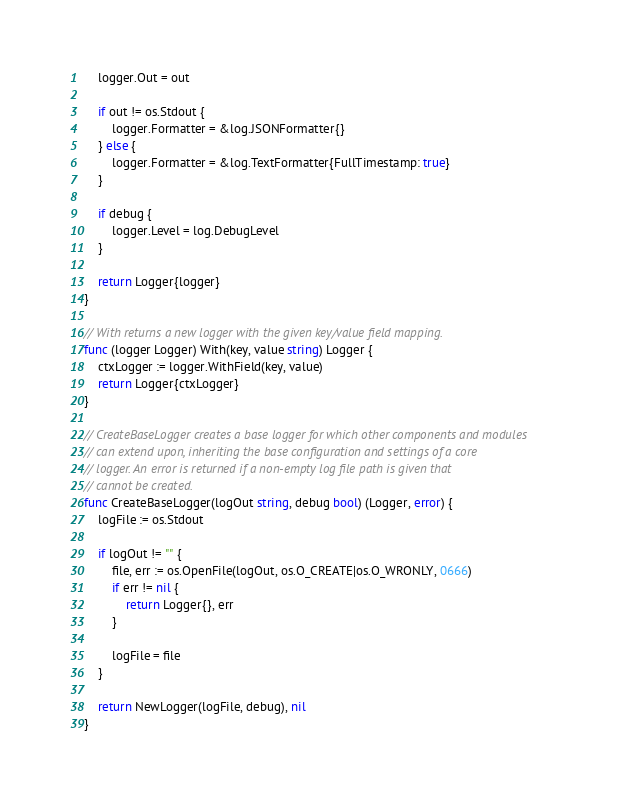<code> <loc_0><loc_0><loc_500><loc_500><_Go_>	logger.Out = out

	if out != os.Stdout {
		logger.Formatter = &log.JSONFormatter{}
	} else {
		logger.Formatter = &log.TextFormatter{FullTimestamp: true}
	}

	if debug {
		logger.Level = log.DebugLevel
	}

	return Logger{logger}
}

// With returns a new logger with the given key/value field mapping.
func (logger Logger) With(key, value string) Logger {
	ctxLogger := logger.WithField(key, value)
	return Logger{ctxLogger}
}

// CreateBaseLogger creates a base logger for which other components and modules
// can extend upon, inheriting the base configuration and settings of a core
// logger. An error is returned if a non-empty log file path is given that
// cannot be created.
func CreateBaseLogger(logOut string, debug bool) (Logger, error) {
	logFile := os.Stdout

	if logOut != "" {
		file, err := os.OpenFile(logOut, os.O_CREATE|os.O_WRONLY, 0666)
		if err != nil {
			return Logger{}, err
		}

		logFile = file
	}

	return NewLogger(logFile, debug), nil
}
</code> 